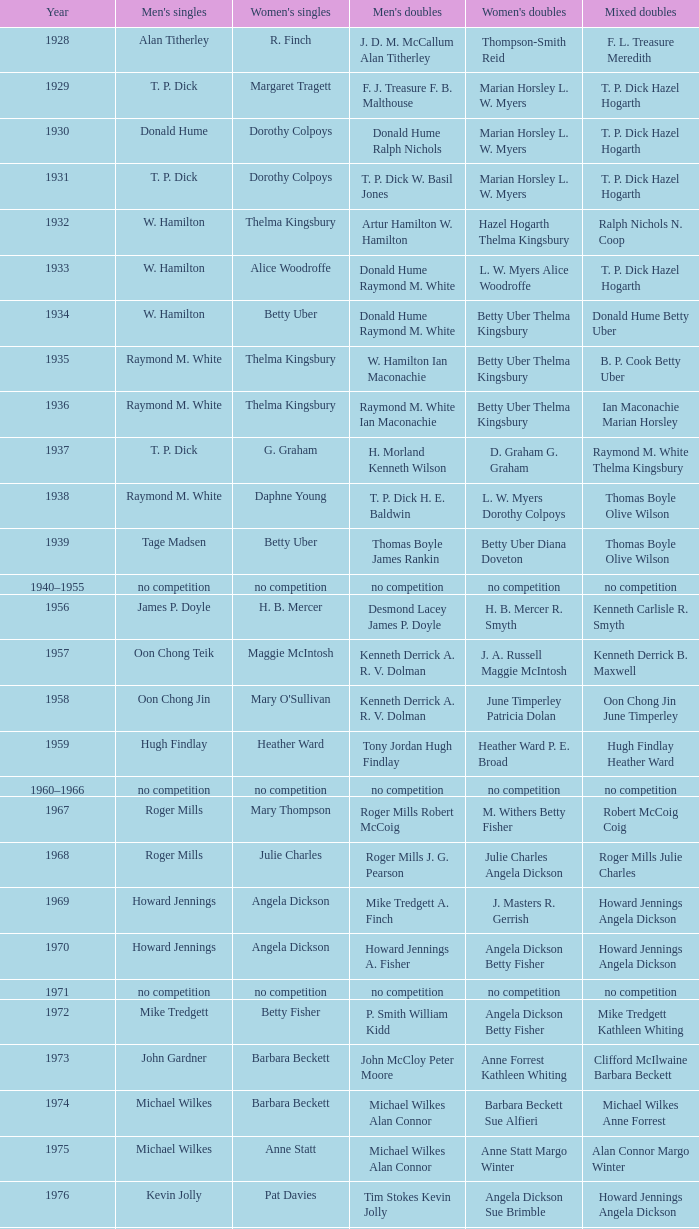Who claimed victory in the women's singles, in the same year that raymond m. white achieved success in the men's singles and w. hamilton ian maconachie conquered the men's doubles? Thelma Kingsbury. 